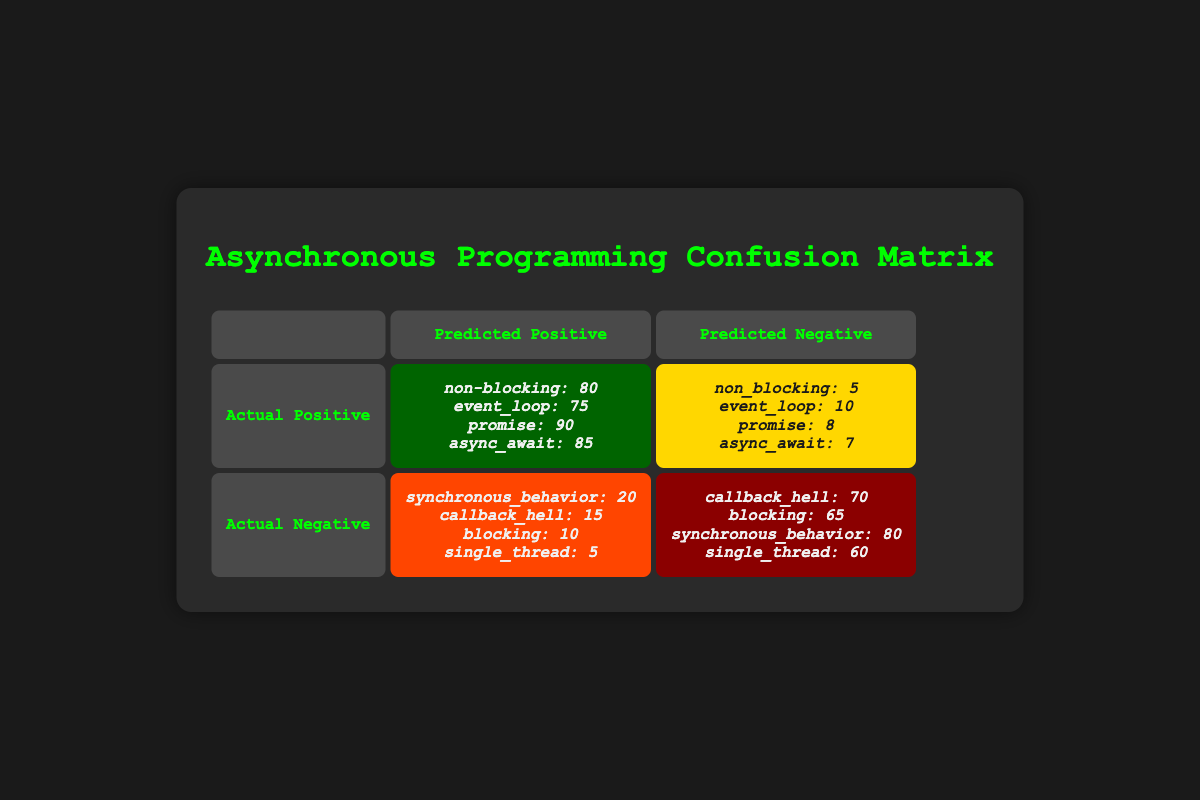What is the total number of true positives for all concepts? To find the total number of true positives, we add the values for non-blocking (80), event loop (75), promise (90), and async await (85). The calculation is 80 + 75 + 90 + 85 = 330.
Answer: 330 What is the value for the false positive related to synchronous behavior? The value for synchronous behavior under false positives is clearly stated in the corresponding cell as 20.
Answer: 20 Which concept had the highest false negative rate? To determine which concept had the highest false negative, we check the false negatives: non-blocking (5), event loop (10), promise (8), async await (7). The maximum value among these is for event loop, which is 10.
Answer: Event loop What is the total number of true negatives when comparing callback hell and blocking? The true negatives for callback hell is 70 and for blocking is 65. Summing these two values gives 70 + 65 = 135.
Answer: 135 Are there more true positives for async await or false negatives for it? The true positives for async await is 85, while the false negatives for it is 7. Since 85 is greater than 7, the answer is yes.
Answer: Yes What is the relationship between false positives and true negatives for single thread? The false positive value for single thread is 5, while the true negative value is 60. Since true negatives are significantly higher than false positives, it indicates that this concept is well understood.
Answer: True negatives are higher Which concept has the largest discrepancy between true positives and false negatives? We calculate the difference between true positives and false negatives for each concept. For non-blocking: 80 - 5 = 75; event loop: 75 - 10 = 65; promise: 90 - 8 = 82; async await: 85 - 7 = 78. The largest discrepancy is for promise, with a difference of 82.
Answer: Promise How many incorrect understandings (false positives) are there in total? The total of the false positives are: synchronous behavior (20), callback hell (15), blocking (10), and single thread (5). The sum is 20 + 15 + 10 + 5 = 50.
Answer: 50 Which concept shows the least misunderstanding based on the true negatives? The lowest true negative value is for single thread (60). This indicates a relatively higher understanding compared to the other concepts.
Answer: Single thread 